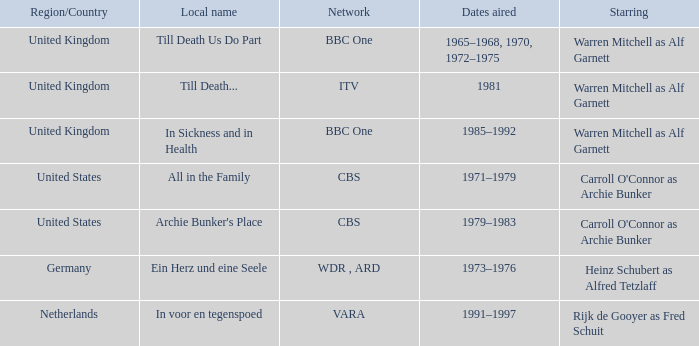What is the regional term for the episodes aired during 1981? Till Death... 